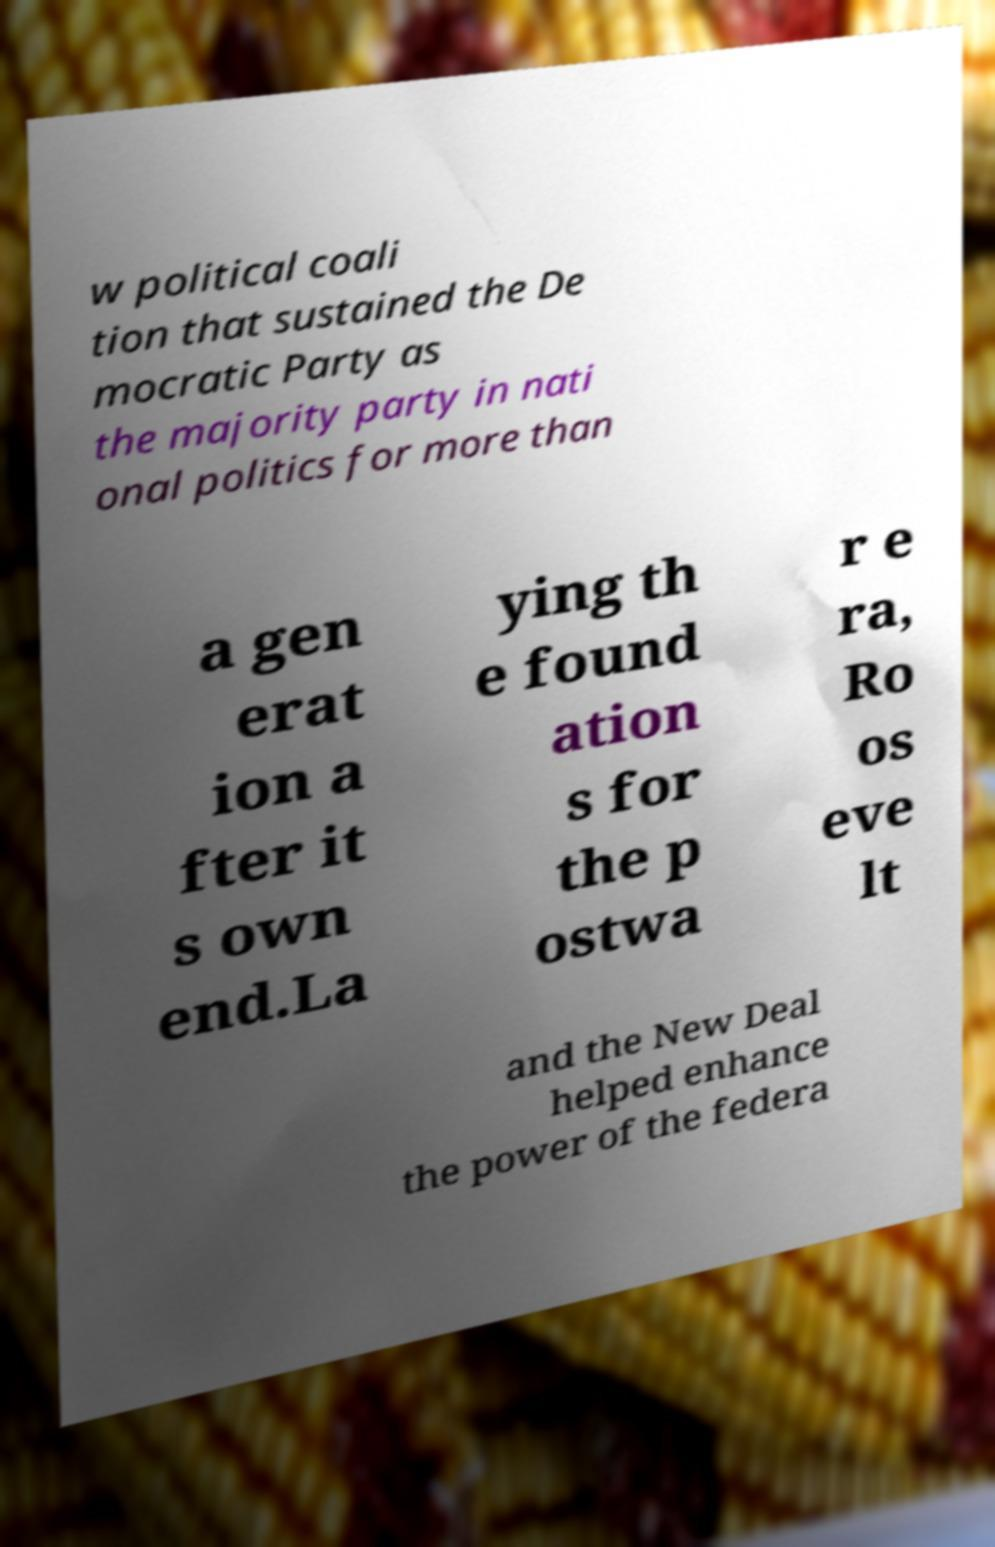There's text embedded in this image that I need extracted. Can you transcribe it verbatim? w political coali tion that sustained the De mocratic Party as the majority party in nati onal politics for more than a gen erat ion a fter it s own end.La ying th e found ation s for the p ostwa r e ra, Ro os eve lt and the New Deal helped enhance the power of the federa 